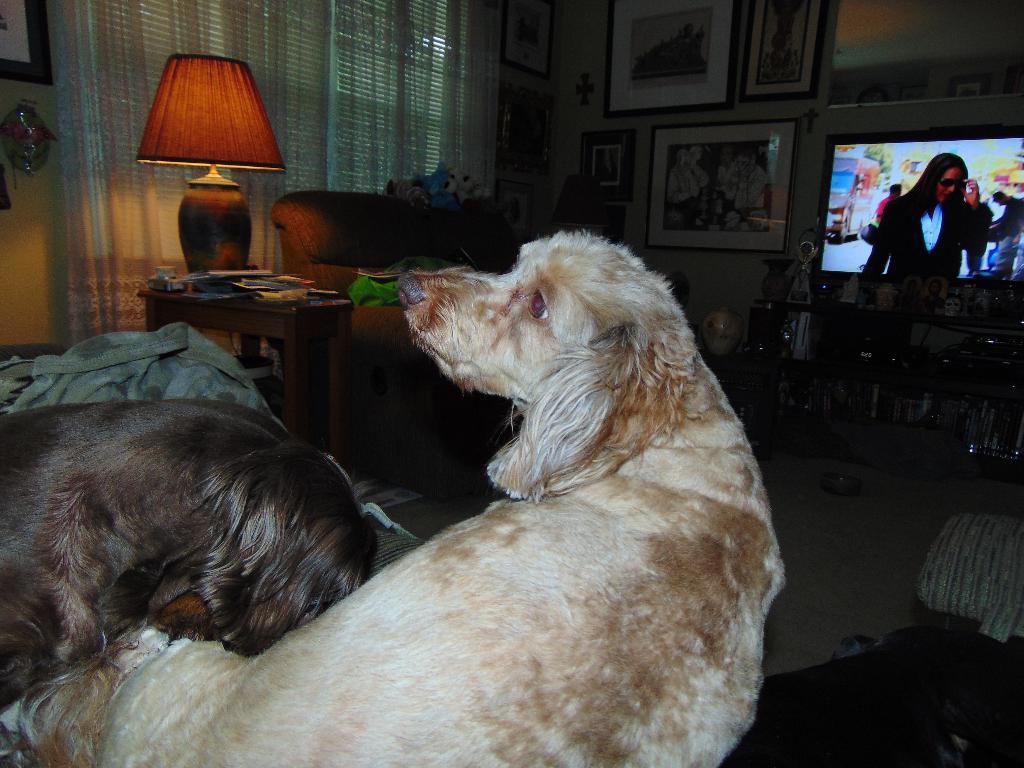Could you give a brief overview of what you see in this image? This is a room. We can see a tv over here,there are two dogs which is one is white color one is black color lying on the sofa, there is a bed sheet beside the dogs. This is a table and this is a lamp on the table and this is a curtain and there are few photos stick to the wall there is another sofa beside the table. There are few articles which are placed below the television. 